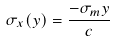Convert formula to latex. <formula><loc_0><loc_0><loc_500><loc_500>\sigma _ { x } ( y ) = \frac { - \sigma _ { m } y } { c }</formula> 